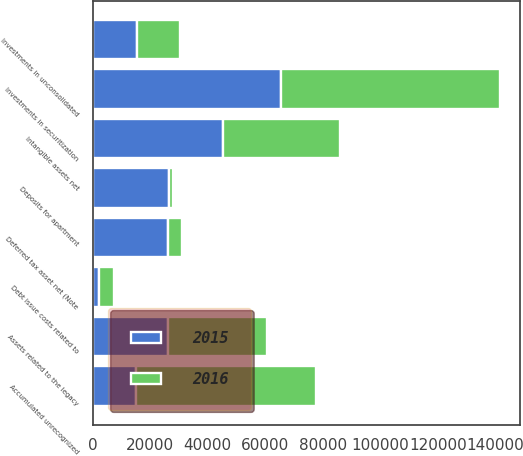Convert chart. <chart><loc_0><loc_0><loc_500><loc_500><stacked_bar_chart><ecel><fcel>Investments in securitization<fcel>Intangible assets net<fcel>Investments in unconsolidated<fcel>Debt issue costs related to<fcel>Deferred tax asset net (Note<fcel>Accumulated unrecognized<fcel>Deposits for apartment<fcel>Assets related to the legacy<nl><fcel>2016<fcel>76063<fcel>40668<fcel>14983<fcel>5250<fcel>5076<fcel>62468<fcel>1404<fcel>34397<nl><fcel>2015<fcel>65502<fcel>45447<fcel>15401<fcel>2107<fcel>26117<fcel>15099<fcel>26632<fcel>26117<nl></chart> 